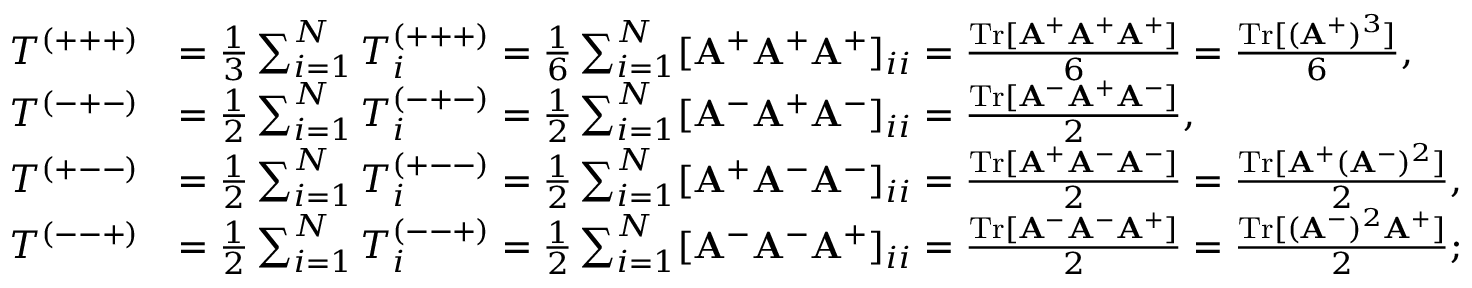Convert formula to latex. <formula><loc_0><loc_0><loc_500><loc_500>\begin{array} { r l } { T ^ { ( + + + ) } } & { = \frac { 1 } { 3 } \sum _ { i = 1 } ^ { N } T _ { i } ^ { ( + + + ) } = \frac { 1 } { 6 } \sum _ { i = 1 } ^ { N } [ A ^ { + } A ^ { + } A ^ { + } ] _ { i i } = \frac { T r [ A ^ { + } A ^ { + } A ^ { + } ] } { 6 } = \frac { T r [ ( A ^ { + } ) ^ { 3 } ] } { 6 } , } \\ { T ^ { ( - + - ) } } & { = \frac { 1 } { 2 } \sum _ { i = 1 } ^ { N } T _ { i } ^ { ( - + - ) } = \frac { 1 } { 2 } \sum _ { i = 1 } ^ { N } [ A ^ { - } A ^ { + } A ^ { - } ] _ { i i } = \frac { T r [ A ^ { - } A ^ { + } A ^ { - } ] } { 2 } , } \\ { T ^ { ( + - - ) } } & { = \frac { 1 } { 2 } \sum _ { i = 1 } ^ { N } T _ { i } ^ { ( + - - ) } = \frac { 1 } { 2 } \sum _ { i = 1 } ^ { N } [ A ^ { + } \mathbf A ^ { - } A ^ { - } ] _ { i i } = \frac { T r [ A ^ { + } A ^ { - } A ^ { - } ] } { 2 } = \frac { T r [ A ^ { + } ( A ^ { - } ) ^ { 2 } ] } { 2 } , } \\ { T ^ { ( - - + ) } } & { = \frac { 1 } { 2 } \sum _ { i = 1 } ^ { N } T _ { i } ^ { ( - - + ) } = \frac { 1 } { 2 } \sum _ { i = 1 } ^ { N } [ A ^ { - } A ^ { - } A ^ { + } ] _ { i i } = \frac { T r [ A ^ { - } \mathbf A ^ { - } A ^ { + } ] } { 2 } = \frac { T r [ ( A ^ { - } ) ^ { 2 } A ^ { + } ] } { 2 } ; } \end{array}</formula> 